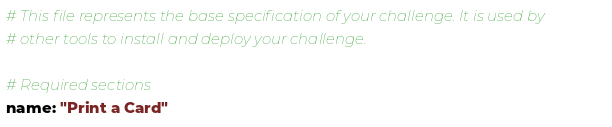Convert code to text. <code><loc_0><loc_0><loc_500><loc_500><_YAML_># This file represents the base specification of your challenge. It is used by
# other tools to install and deploy your challenge.

# Required sections
name: "Print a Card"</code> 